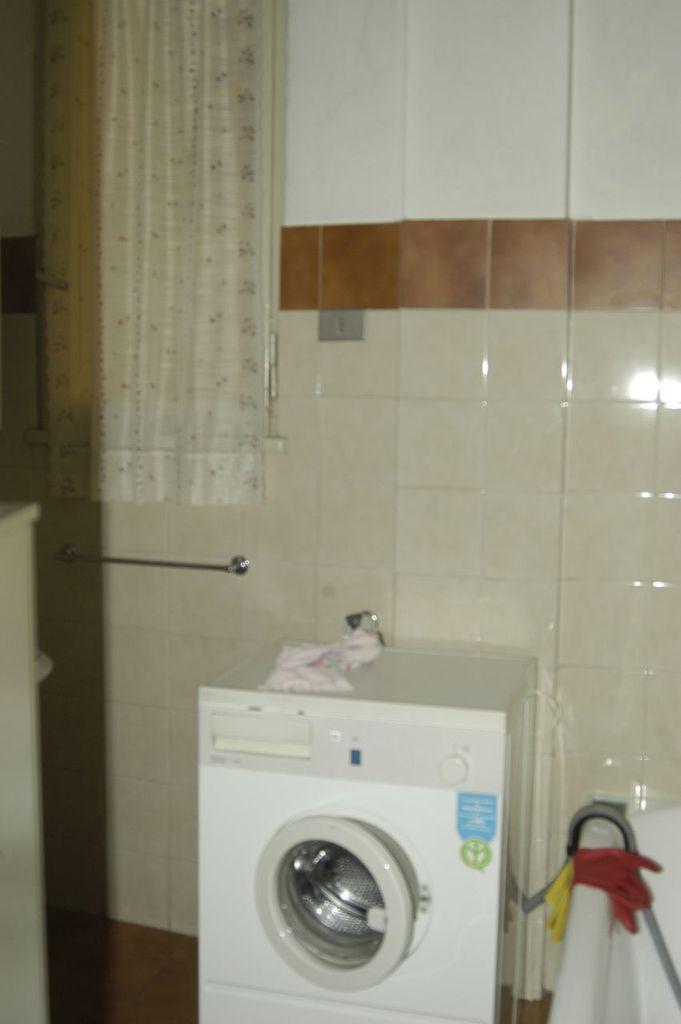Could you give a brief overview of what you see in this image? In this image in the middle, there is a washing machine. On the right there is a sink. In the background there is a curtain, tiles and wall. 